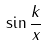Convert formula to latex. <formula><loc_0><loc_0><loc_500><loc_500>\sin \frac { k } { x }</formula> 